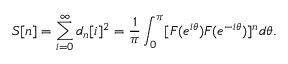<formula> <loc_0><loc_0><loc_500><loc_500>S [ n ] = \sum _ { i = 0 } ^ { \infty } d _ { n } [ i ] ^ { 2 } = \frac { 1 } { \pi } \int _ { 0 } ^ { \pi } [ F ( e ^ { i \theta } ) F ( e ^ { - i \theta } ) ] ^ { n } d \theta .</formula> 